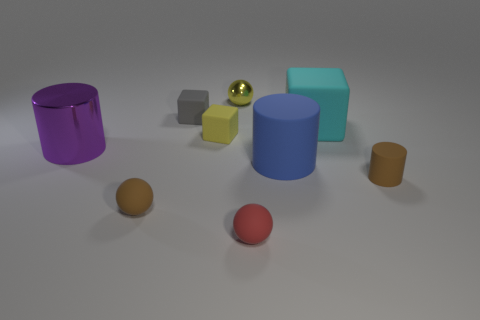Add 1 tiny red spheres. How many objects exist? 10 Subtract all spheres. How many objects are left? 6 Add 1 small yellow objects. How many small yellow objects are left? 3 Add 2 large things. How many large things exist? 5 Subtract 0 brown cubes. How many objects are left? 9 Subtract all tiny brown rubber cylinders. Subtract all tiny gray matte things. How many objects are left? 7 